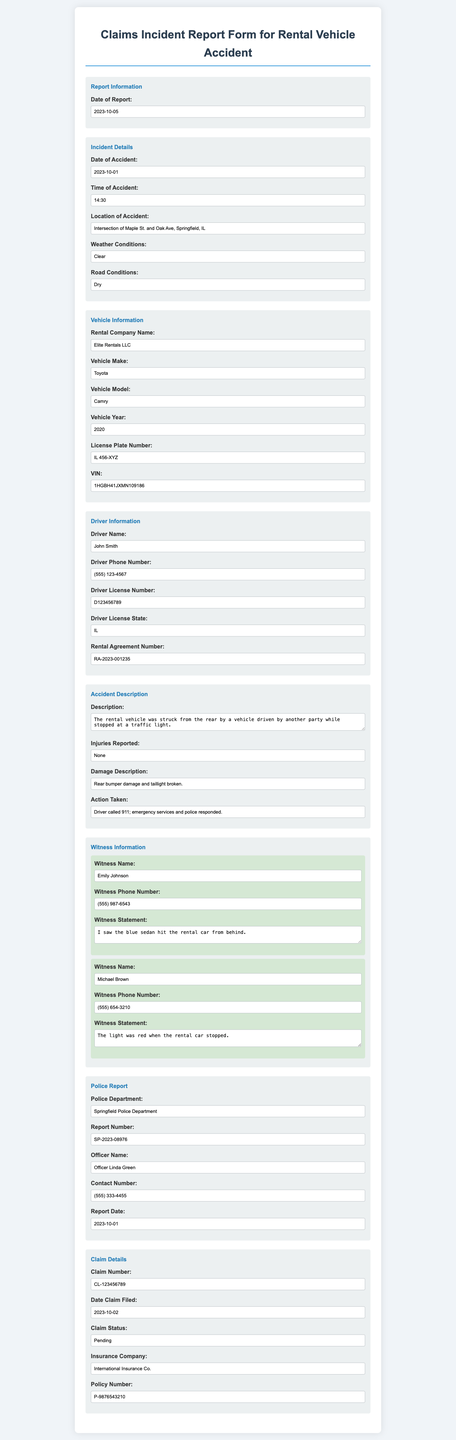What is the date of the accident? The date of the accident is mentioned in the Incident Details section of the document.
Answer: 2023-10-01 What is the name of the rental company? The rental company name is listed under Vehicle Information in the document.
Answer: Elite Rentals LLC What weather conditions were reported at the time of the accident? The weather conditions during the accident are provided in the Incident Details section.
Answer: Clear Who is the driver of the rental vehicle? The driver's name can be found in the Driver Information section of the document.
Answer: John Smith What is the police report number? The report number is stated under the Police Report section of the form.
Answer: SP-2023-08976 How many witness statements are provided in the report? The document contains separate sections for each witness, indicating distinct statements.
Answer: 2 What was the damage description reported? The damage description is located in the Accident Description section of the document.
Answer: Rear bumper damage and taillight broken What action was taken after the accident? The actions taken post-accident are outlined in the Accident Description section.
Answer: Driver called 911; emergency services and police responded Is there any injury reported in the document? The Injuries Reported section discusses the presence or absence of injuries.
Answer: None 